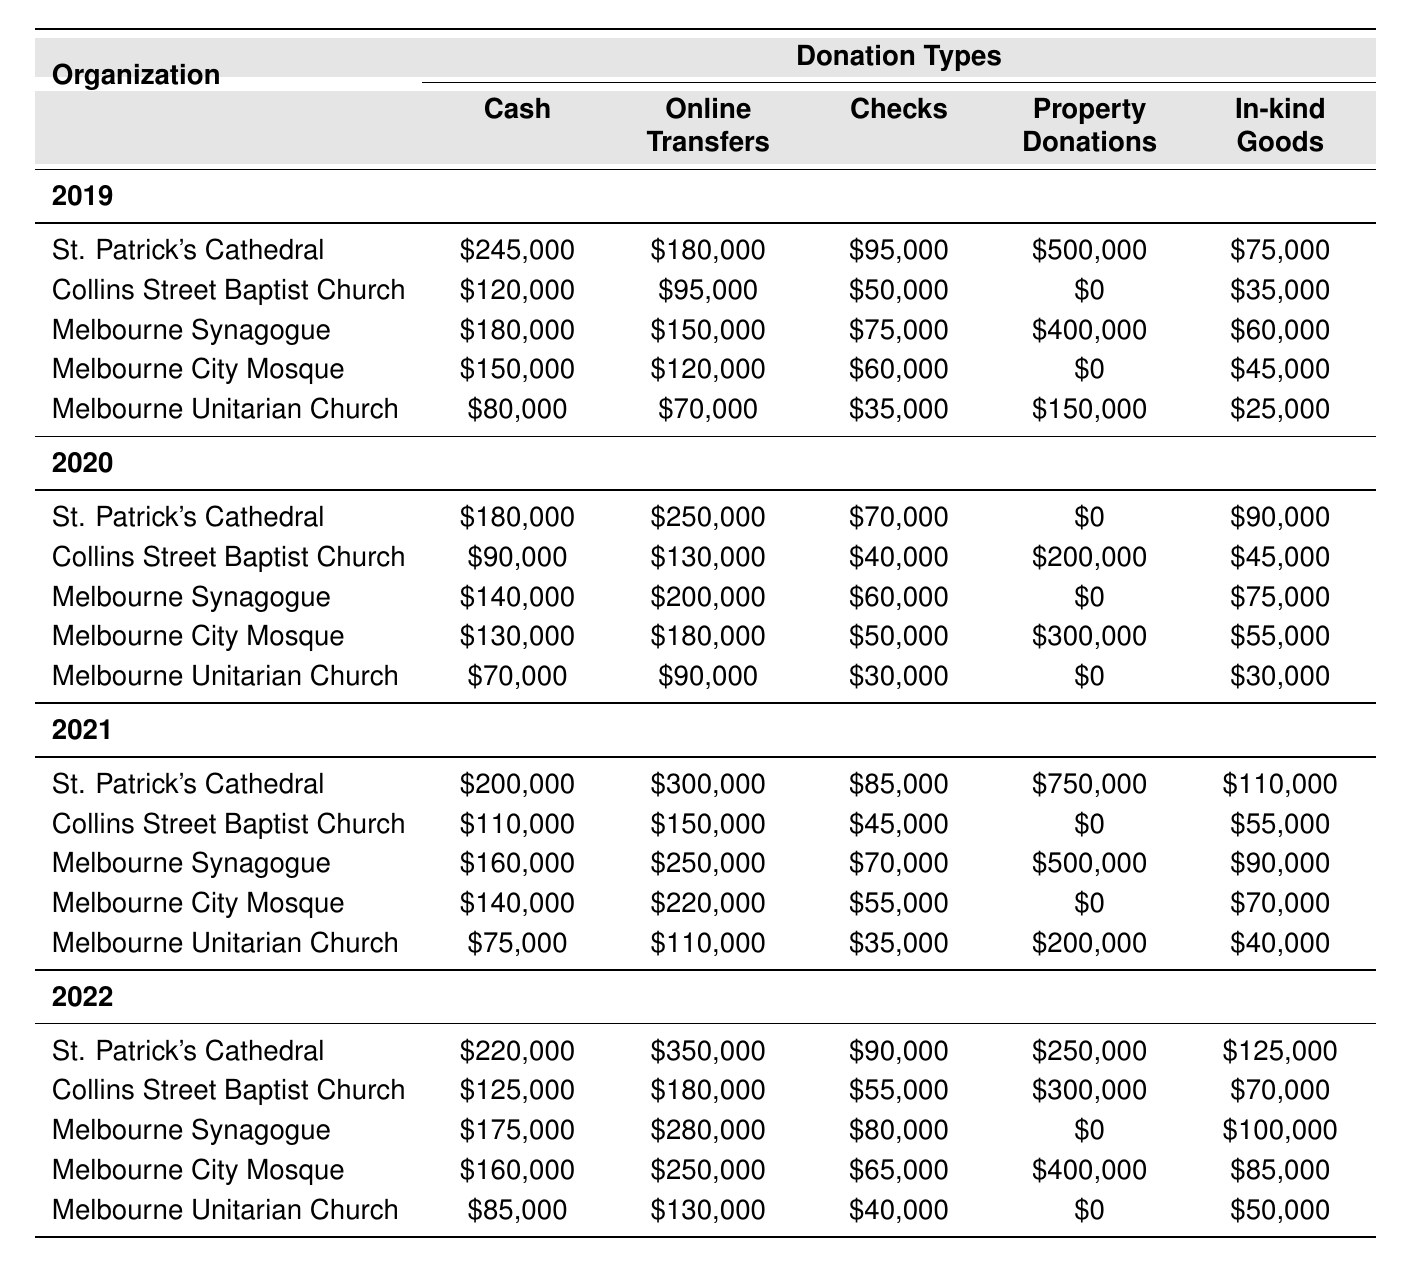What was the total cash donation received by St. Patrick's Cathedral in 2021? Adding the cash donations in the year 2021 from St. Patrick's Cathedral, we see it received $200,000.
Answer: $200,000 Which organization received the highest amount in property donations in 2019? Looking at the property donations for 2019, St. Patrick's Cathedral received $500,000, which is the highest among all organizations listed.
Answer: St. Patrick's Cathedral What is the average online transfer donation across all organizations in 2022? To find the average, sum the online transfer donations for 2022: $350,000 (St. Patrick's) + $180,000 (Collins St.) + $280,000 (Melbourne Synagogue) + $250,000 (Melbourne City Mosque) + $130,000 (Unitarian Church) = $1,190,000. There are 5 organizations, so the average is $1,190,000 / 5 = $238,000.
Answer: $238,000 Did Collins Street Baptist Church have any property donations in 2019? By checking the table for Collins Street Baptist Church in 2019, we see that the property donations are listed as $0, indicating there were no donations that year.
Answer: No What was the percentage increase in total cash donations to Melbourne City Mosque from 2019 to 2022? In 2019, cash donations to Melbourne City Mosque were $150,000 and in 2022 they were $160,000. The increase is $160,000 - $150,000 = $10,000. To find the percentage increase, use the formula (increase/original amount) * 100 = ($10,000 / $150,000) * 100 = 6.67%.
Answer: 6.67% Which organization had the least amount of in-kind goods donations in 2020? Reviewing the in-kind goods donations for 2020, Melbourne Unitarian Church received $30,000, which is less than the other organizations listed.
Answer: Melbourne Unitarian Church What is the sum of all checks donations received by Melbourne Synagogue from 2019 to 2022? Adding the checks donations from all four years: $75,000 (2019) + $60,000 (2020) + $70,000 (2021) + $80,000 (2022) = $285,000 in total checks donations.
Answer: $285,000 Was there a year when the cash donations from St. Paul’s Cathedral were recorded in this dataset? St. Paul's Cathedral does not appear in the data provided for any year, indicating there are no recorded cash donations for this organization.
Answer: No Which type of donation has the highest total across all organizations for the year 2021? For 2021, the cash donations total $200,000 + $110,000 + $160,000 + $140,000 + $75,000 = $685,000; the online transfers total $300,000 + $150,000 + $250,000 + $220,000 + $110,000 = $1,030,000. The highest total is for online transfers.
Answer: Online Transfers How did the checks donations to Melbourne Unitarian Church change from 2019 to 2022? In 2019, Melbourne Unitarian Church received $35,000 in checks, and in 2022, they received $40,000. The change is $40,000 - $35,000 = $5,000, indicating an increase.
Answer: Increased by $5,000 